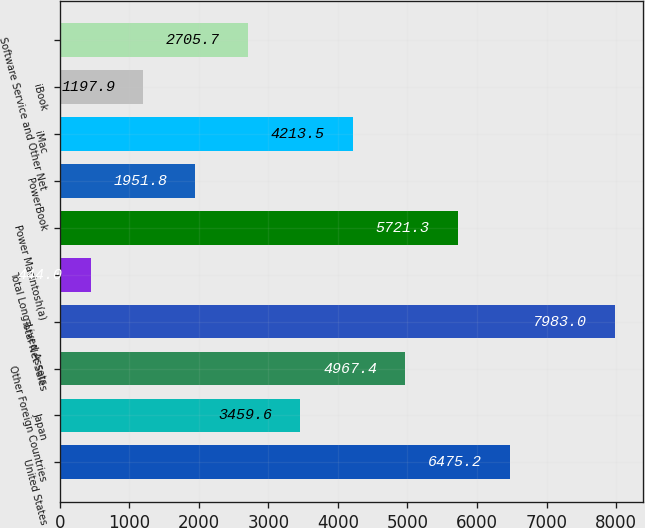<chart> <loc_0><loc_0><loc_500><loc_500><bar_chart><fcel>United States<fcel>Japan<fcel>Other Foreign Countries<fcel>Total Net Sales<fcel>Total Long-Lived Assets<fcel>Power Macintosh(a)<fcel>PowerBook<fcel>iMac<fcel>iBook<fcel>Software Service and Other Net<nl><fcel>6475.2<fcel>3459.6<fcel>4967.4<fcel>7983<fcel>444<fcel>5721.3<fcel>1951.8<fcel>4213.5<fcel>1197.9<fcel>2705.7<nl></chart> 